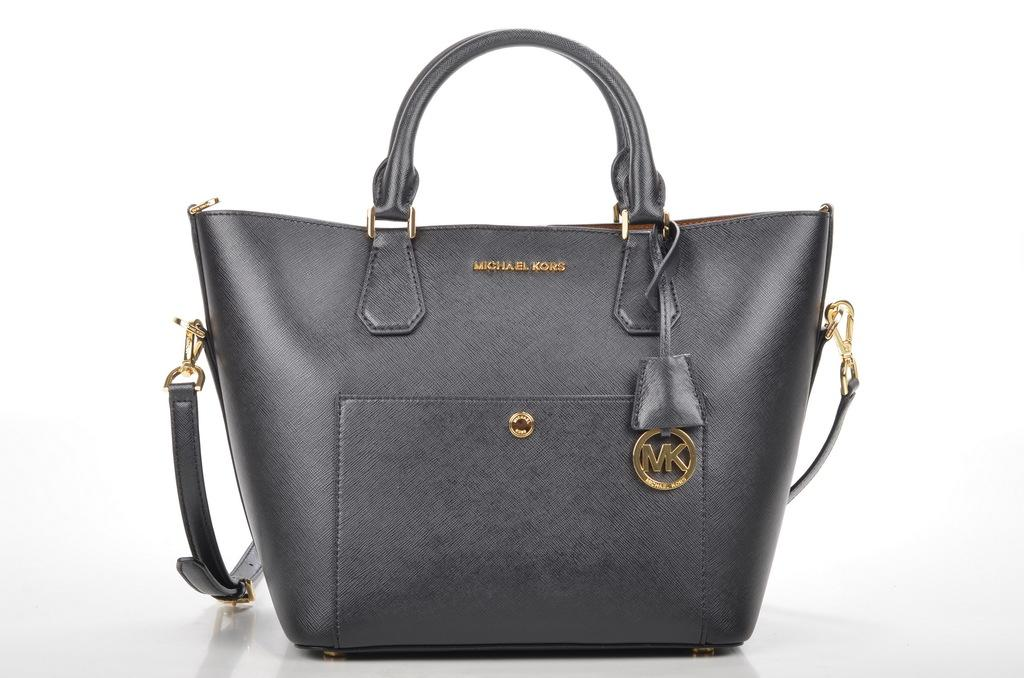What type of accessory is in the center of the image? There is a black handbag in the center of the image. Can you describe the position of the handbag in the image? The handbag is in the center of the image. What type of wall is visible behind the handbag in the image? There is no wall visible behind the handbag in the image; it is not mentioned in the provided facts. 